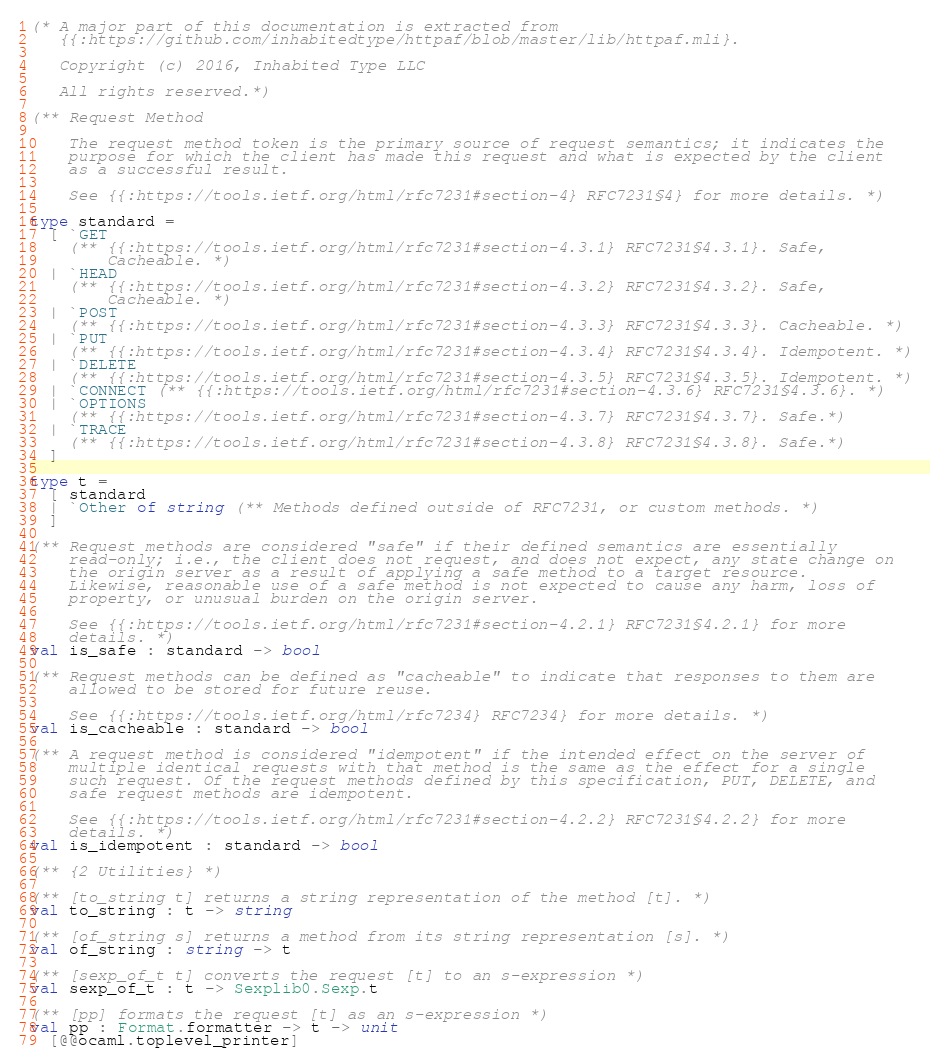Convert code to text. <code><loc_0><loc_0><loc_500><loc_500><_OCaml_>(* A major part of this documentation is extracted from
   {{:https://github.com/inhabitedtype/httpaf/blob/master/lib/httpaf.mli}.

   Copyright (c) 2016, Inhabited Type LLC

   All rights reserved.*)

(** Request Method

    The request method token is the primary source of request semantics; it indicates the
    purpose for which the client has made this request and what is expected by the client
    as a successful result.

    See {{:https://tools.ietf.org/html/rfc7231#section-4} RFC7231§4} for more details. *)

type standard =
  [ `GET
    (** {{:https://tools.ietf.org/html/rfc7231#section-4.3.1} RFC7231§4.3.1}. Safe,
        Cacheable. *)
  | `HEAD
    (** {{:https://tools.ietf.org/html/rfc7231#section-4.3.2} RFC7231§4.3.2}. Safe,
        Cacheable. *)
  | `POST
    (** {{:https://tools.ietf.org/html/rfc7231#section-4.3.3} RFC7231§4.3.3}. Cacheable. *)
  | `PUT
    (** {{:https://tools.ietf.org/html/rfc7231#section-4.3.4} RFC7231§4.3.4}. Idempotent. *)
  | `DELETE
    (** {{:https://tools.ietf.org/html/rfc7231#section-4.3.5} RFC7231§4.3.5}. Idempotent. *)
  | `CONNECT (** {{:https://tools.ietf.org/html/rfc7231#section-4.3.6} RFC7231§4.3.6}. *)
  | `OPTIONS
    (** {{:https://tools.ietf.org/html/rfc7231#section-4.3.7} RFC7231§4.3.7}. Safe.*)
  | `TRACE
    (** {{:https://tools.ietf.org/html/rfc7231#section-4.3.8} RFC7231§4.3.8}. Safe.*)
  ]

type t =
  [ standard
  | `Other of string (** Methods defined outside of RFC7231, or custom methods. *)
  ]

(** Request methods are considered "safe" if their defined semantics are essentially
    read-only; i.e., the client does not request, and does not expect, any state change on
    the origin server as a result of applying a safe method to a target resource.
    Likewise, reasonable use of a safe method is not expected to cause any harm, loss of
    property, or unusual burden on the origin server.

    See {{:https://tools.ietf.org/html/rfc7231#section-4.2.1} RFC7231§4.2.1} for more
    details. *)
val is_safe : standard -> bool

(** Request methods can be defined as "cacheable" to indicate that responses to them are
    allowed to be stored for future reuse.

    See {{:https://tools.ietf.org/html/rfc7234} RFC7234} for more details. *)
val is_cacheable : standard -> bool

(** A request method is considered "idempotent" if the intended effect on the server of
    multiple identical requests with that method is the same as the effect for a single
    such request. Of the request methods defined by this specification, PUT, DELETE, and
    safe request methods are idempotent.

    See {{:https://tools.ietf.org/html/rfc7231#section-4.2.2} RFC7231§4.2.2} for more
    details. *)
val is_idempotent : standard -> bool

(** {2 Utilities} *)

(** [to_string t] returns a string representation of the method [t]. *)
val to_string : t -> string

(** [of_string s] returns a method from its string representation [s]. *)
val of_string : string -> t

(** [sexp_of_t t] converts the request [t] to an s-expression *)
val sexp_of_t : t -> Sexplib0.Sexp.t

(** [pp] formats the request [t] as an s-expression *)
val pp : Format.formatter -> t -> unit
  [@@ocaml.toplevel_printer]
</code> 